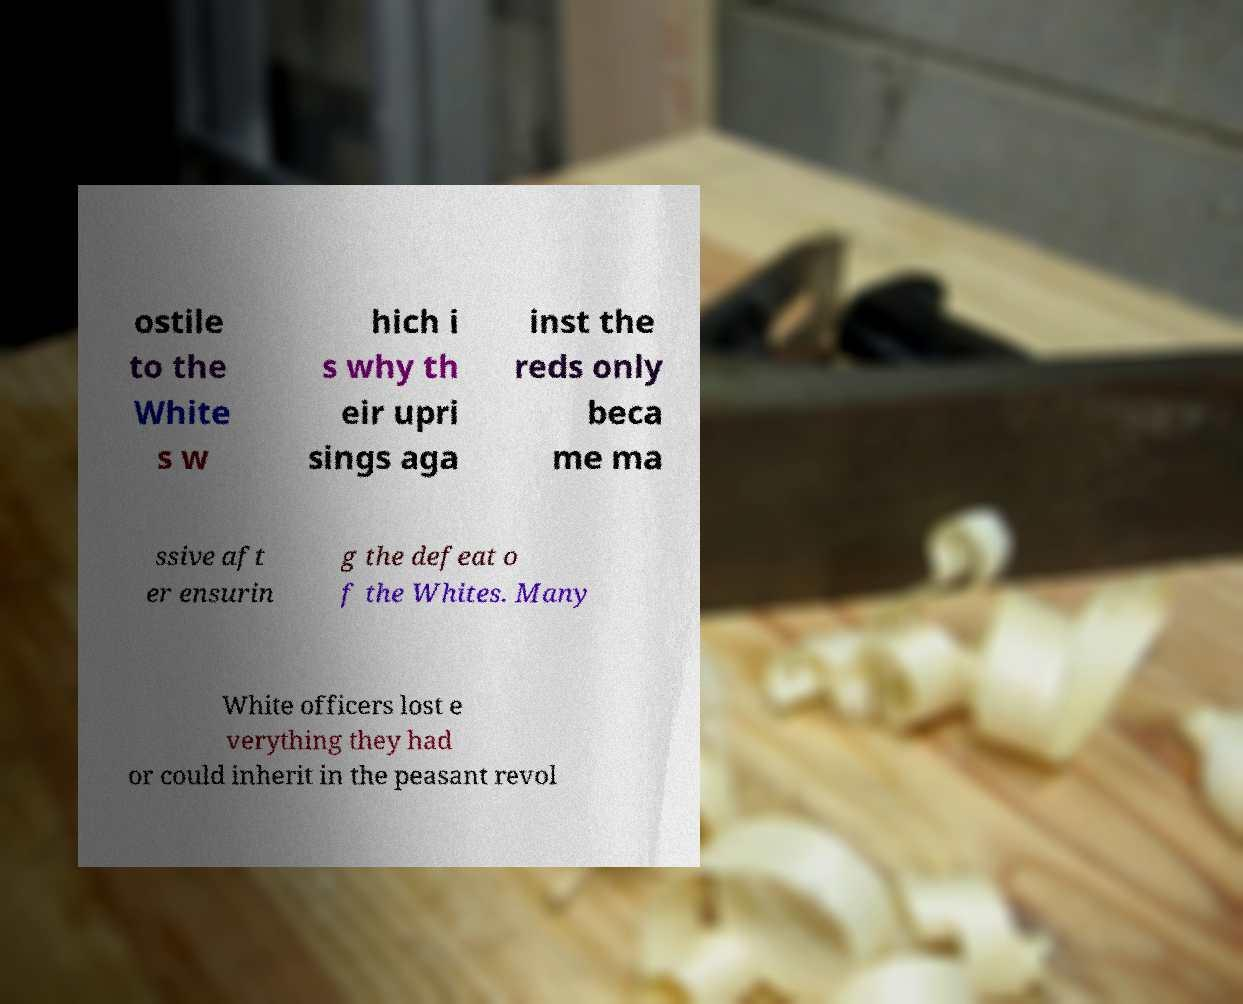I need the written content from this picture converted into text. Can you do that? ostile to the White s w hich i s why th eir upri sings aga inst the reds only beca me ma ssive aft er ensurin g the defeat o f the Whites. Many White officers lost e verything they had or could inherit in the peasant revol 